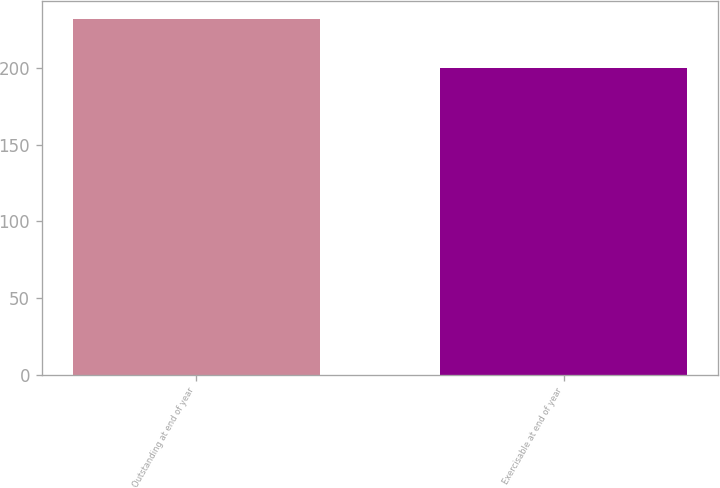Convert chart to OTSL. <chart><loc_0><loc_0><loc_500><loc_500><bar_chart><fcel>Outstanding at end of year<fcel>Exercisable at end of year<nl><fcel>232<fcel>200<nl></chart> 